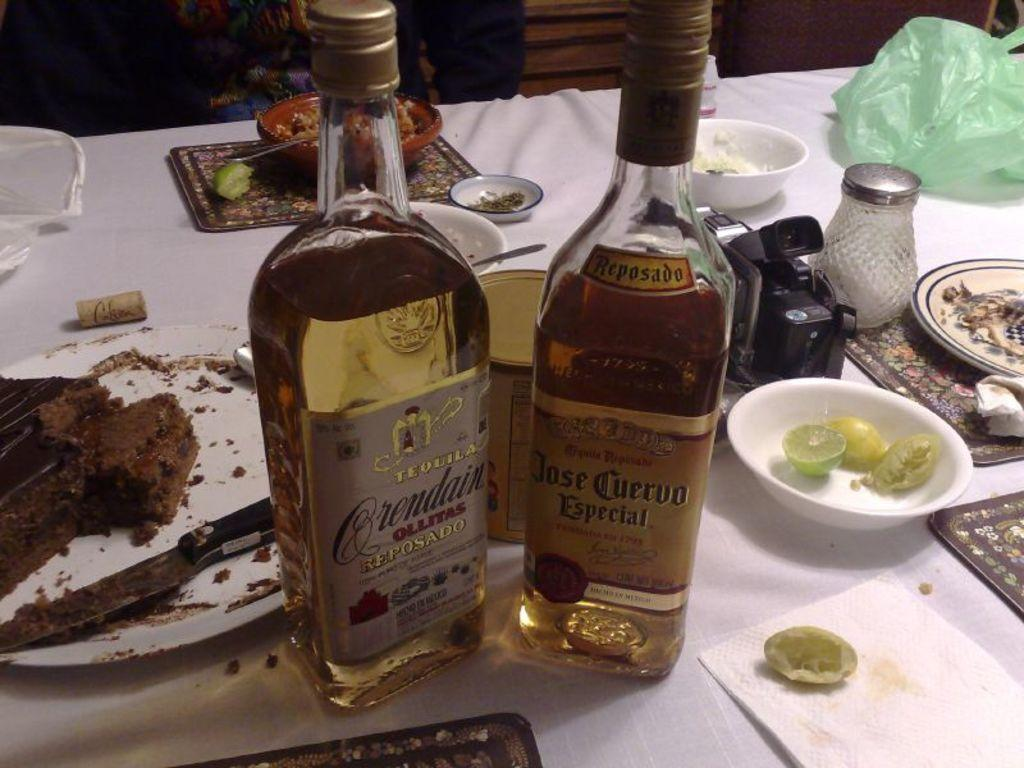<image>
Relay a brief, clear account of the picture shown. A table of food and two bottles of alcohol including Jose Cuervo Especial and another bottle of tequila. 